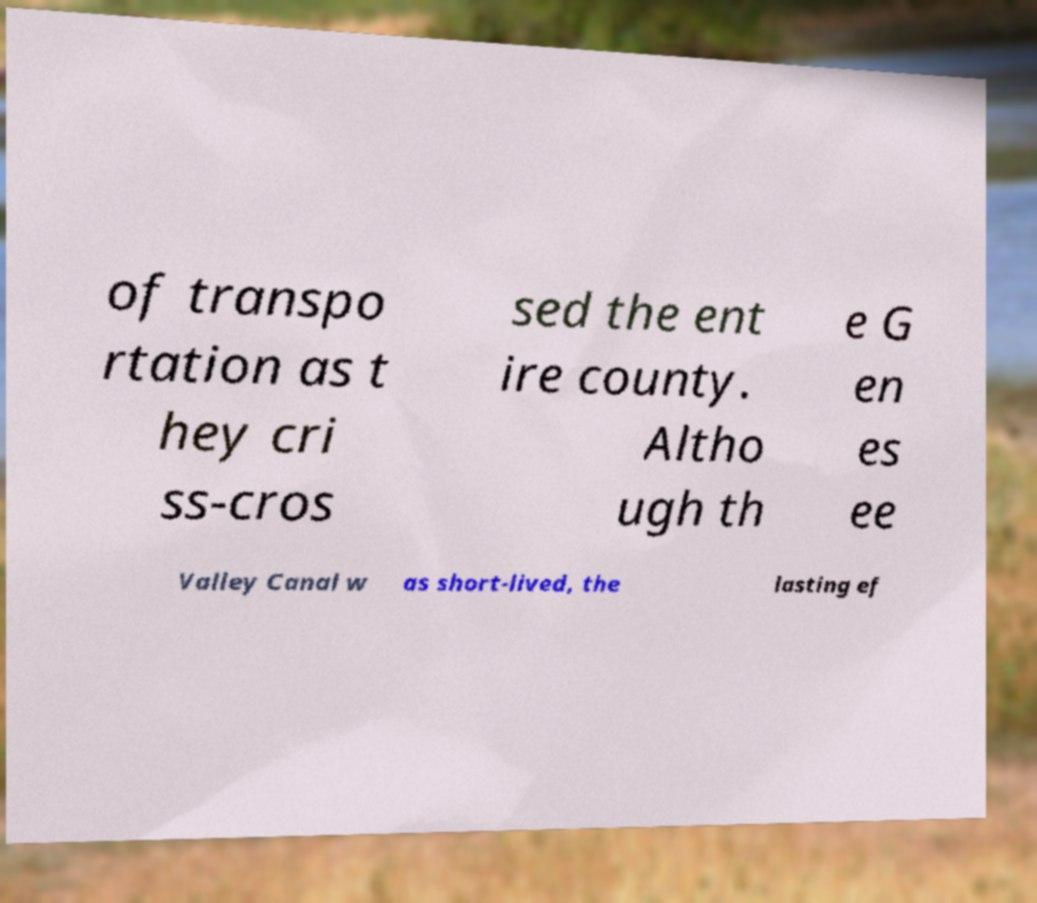Could you assist in decoding the text presented in this image and type it out clearly? of transpo rtation as t hey cri ss-cros sed the ent ire county. Altho ugh th e G en es ee Valley Canal w as short-lived, the lasting ef 